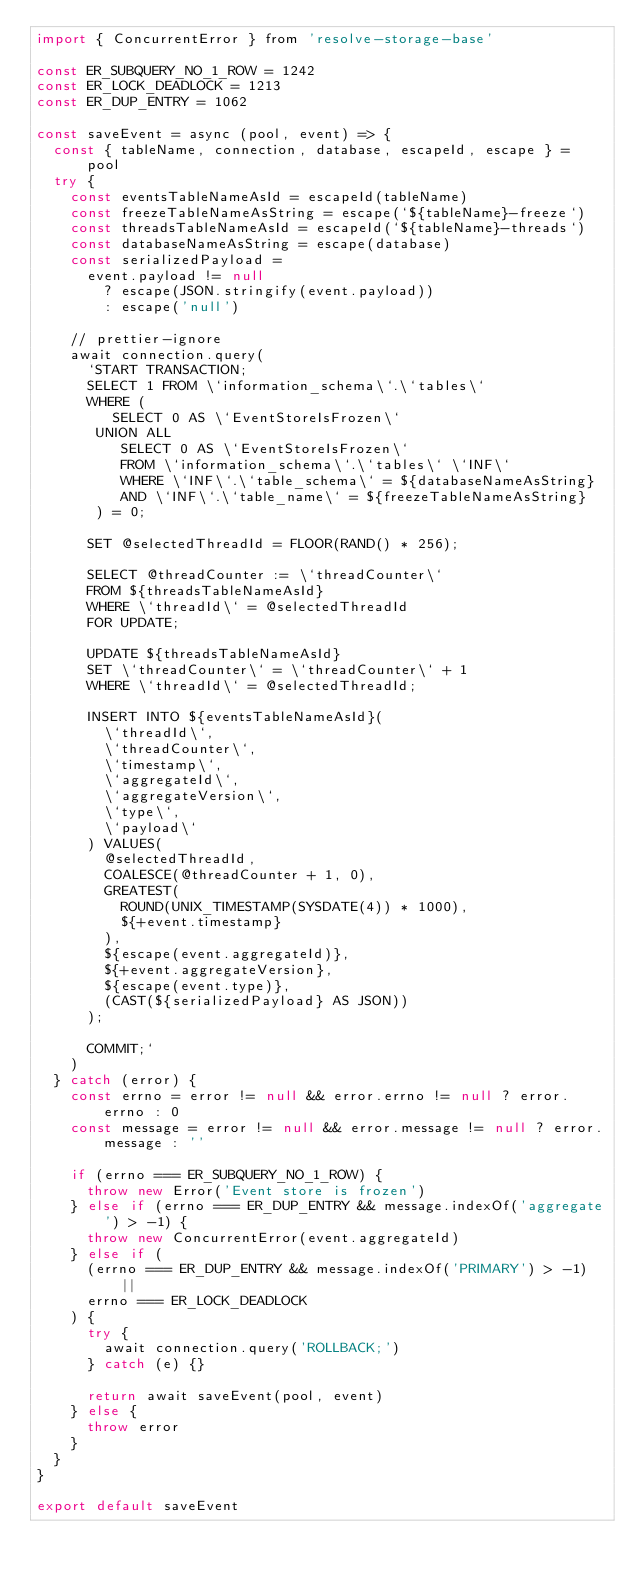Convert code to text. <code><loc_0><loc_0><loc_500><loc_500><_JavaScript_>import { ConcurrentError } from 'resolve-storage-base'

const ER_SUBQUERY_NO_1_ROW = 1242
const ER_LOCK_DEADLOCK = 1213
const ER_DUP_ENTRY = 1062

const saveEvent = async (pool, event) => {
  const { tableName, connection, database, escapeId, escape } = pool
  try {
    const eventsTableNameAsId = escapeId(tableName)
    const freezeTableNameAsString = escape(`${tableName}-freeze`)
    const threadsTableNameAsId = escapeId(`${tableName}-threads`)
    const databaseNameAsString = escape(database)
    const serializedPayload =
      event.payload != null
        ? escape(JSON.stringify(event.payload))
        : escape('null')

    // prettier-ignore
    await connection.query(
      `START TRANSACTION;
      SELECT 1 FROM \`information_schema\`.\`tables\`
      WHERE (
         SELECT 0 AS \`EventStoreIsFrozen\`
       UNION ALL
          SELECT 0 AS \`EventStoreIsFrozen\`
          FROM \`information_schema\`.\`tables\` \`INF\`
          WHERE \`INF\`.\`table_schema\` = ${databaseNameAsString}
          AND \`INF\`.\`table_name\` = ${freezeTableNameAsString}
       ) = 0;
       
      SET @selectedThreadId = FLOOR(RAND() * 256);
      
      SELECT @threadCounter := \`threadCounter\`
      FROM ${threadsTableNameAsId}
      WHERE \`threadId\` = @selectedThreadId
      FOR UPDATE;
      
      UPDATE ${threadsTableNameAsId}
      SET \`threadCounter\` = \`threadCounter\` + 1
      WHERE \`threadId\` = @selectedThreadId;
      
      INSERT INTO ${eventsTableNameAsId}(
        \`threadId\`,
        \`threadCounter\`,
        \`timestamp\`,
        \`aggregateId\`,
        \`aggregateVersion\`,
        \`type\`,
        \`payload\`
      ) VALUES(
        @selectedThreadId,
        COALESCE(@threadCounter + 1, 0),
        GREATEST(
          ROUND(UNIX_TIMESTAMP(SYSDATE(4)) * 1000),
          ${+event.timestamp}
        ),
        ${escape(event.aggregateId)},
        ${+event.aggregateVersion},
        ${escape(event.type)},
        (CAST(${serializedPayload} AS JSON))
      );
      
      COMMIT;`
    )
  } catch (error) {
    const errno = error != null && error.errno != null ? error.errno : 0
    const message = error != null && error.message != null ? error.message : ''

    if (errno === ER_SUBQUERY_NO_1_ROW) {
      throw new Error('Event store is frozen')
    } else if (errno === ER_DUP_ENTRY && message.indexOf('aggregate') > -1) {
      throw new ConcurrentError(event.aggregateId)
    } else if (
      (errno === ER_DUP_ENTRY && message.indexOf('PRIMARY') > -1) ||
      errno === ER_LOCK_DEADLOCK
    ) {
      try {
        await connection.query('ROLLBACK;')
      } catch (e) {}

      return await saveEvent(pool, event)
    } else {
      throw error
    }
  }
}

export default saveEvent
</code> 